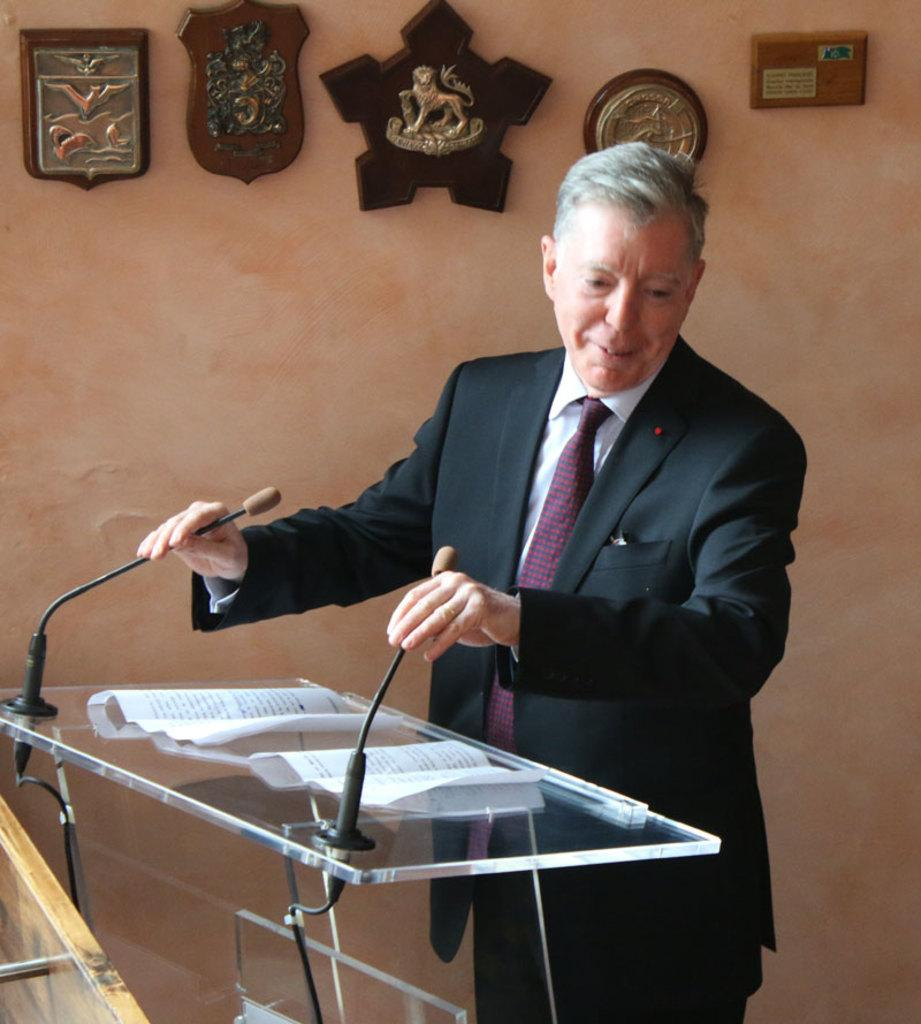What is the person in the image doing? The person is standing in front of a podium. What is on the podium? The podium has a microphone and papers on it. What can be seen in the background of the image? There are frames visible at the back side of the image. Can you see any police officers or tickets in the image? No, there are no police officers or tickets present in the image. Is there a garden visible in the image? No, there is no garden visible in the image; the background features frames. 